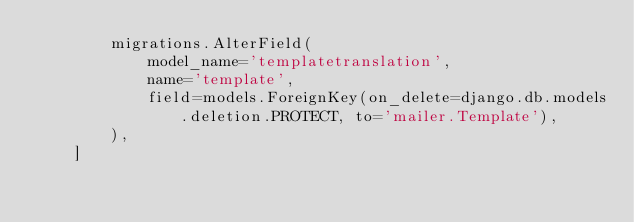Convert code to text. <code><loc_0><loc_0><loc_500><loc_500><_Python_>        migrations.AlterField(
            model_name='templatetranslation',
            name='template',
            field=models.ForeignKey(on_delete=django.db.models.deletion.PROTECT, to='mailer.Template'),
        ),
    ]
</code> 